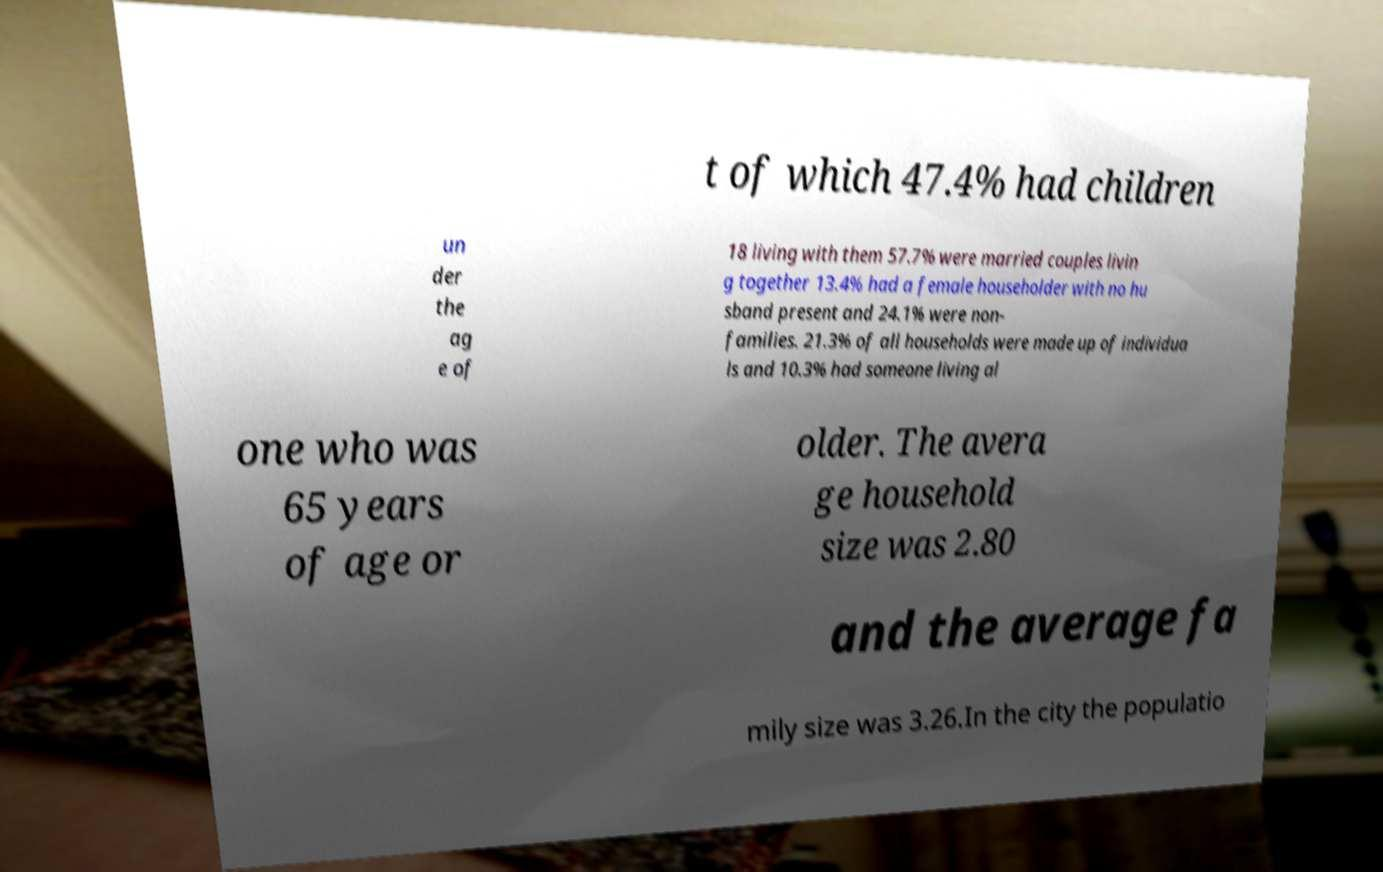I need the written content from this picture converted into text. Can you do that? t of which 47.4% had children un der the ag e of 18 living with them 57.7% were married couples livin g together 13.4% had a female householder with no hu sband present and 24.1% were non- families. 21.3% of all households were made up of individua ls and 10.3% had someone living al one who was 65 years of age or older. The avera ge household size was 2.80 and the average fa mily size was 3.26.In the city the populatio 